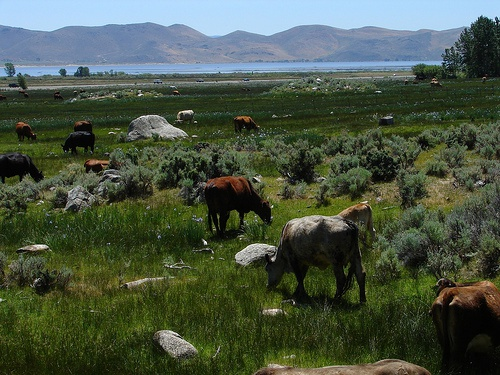Describe the objects in this image and their specific colors. I can see cow in lightblue, black, darkgray, gray, and darkgreen tones, cow in lightblue, black, maroon, and gray tones, cow in lightblue, black, maroon, and brown tones, cow in lightblue, black, gray, and darkgreen tones, and cow in lightblue, black, gray, olive, and tan tones in this image. 